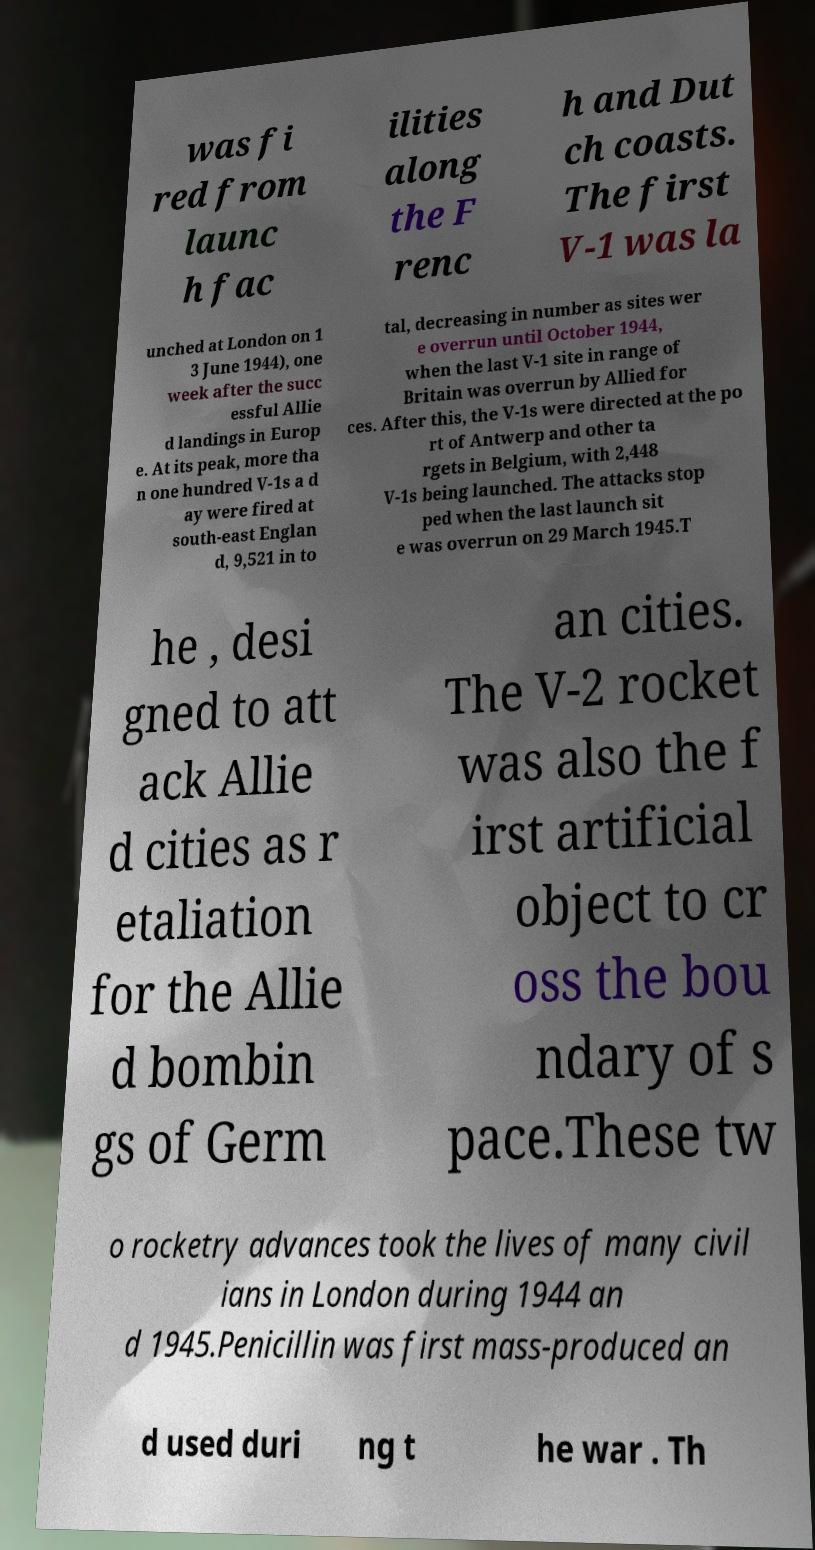There's text embedded in this image that I need extracted. Can you transcribe it verbatim? was fi red from launc h fac ilities along the F renc h and Dut ch coasts. The first V-1 was la unched at London on 1 3 June 1944), one week after the succ essful Allie d landings in Europ e. At its peak, more tha n one hundred V-1s a d ay were fired at south-east Englan d, 9,521 in to tal, decreasing in number as sites wer e overrun until October 1944, when the last V-1 site in range of Britain was overrun by Allied for ces. After this, the V-1s were directed at the po rt of Antwerp and other ta rgets in Belgium, with 2,448 V-1s being launched. The attacks stop ped when the last launch sit e was overrun on 29 March 1945.T he , desi gned to att ack Allie d cities as r etaliation for the Allie d bombin gs of Germ an cities. The V-2 rocket was also the f irst artificial object to cr oss the bou ndary of s pace.These tw o rocketry advances took the lives of many civil ians in London during 1944 an d 1945.Penicillin was first mass-produced an d used duri ng t he war . Th 